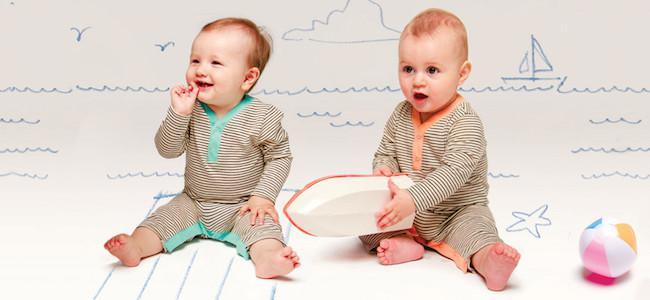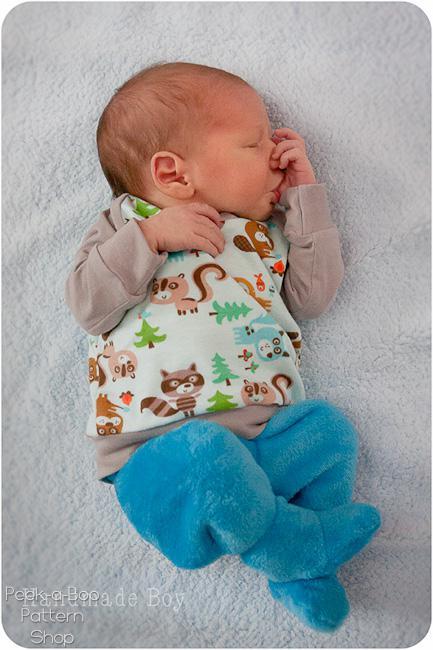The first image is the image on the left, the second image is the image on the right. Evaluate the accuracy of this statement regarding the images: "There is atleast one photo with two girls holding hands". Is it true? Answer yes or no. No. The first image is the image on the left, the second image is the image on the right. Examine the images to the left and right. Is the description "There are three children" accurate? Answer yes or no. Yes. 